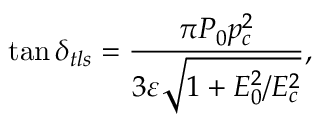Convert formula to latex. <formula><loc_0><loc_0><loc_500><loc_500>\tan \delta _ { t l s } = \frac { \pi P _ { 0 } p _ { c } ^ { 2 } } { 3 \varepsilon \sqrt { 1 + E _ { 0 } ^ { 2 } / E _ { c } ^ { 2 } } } ,</formula> 